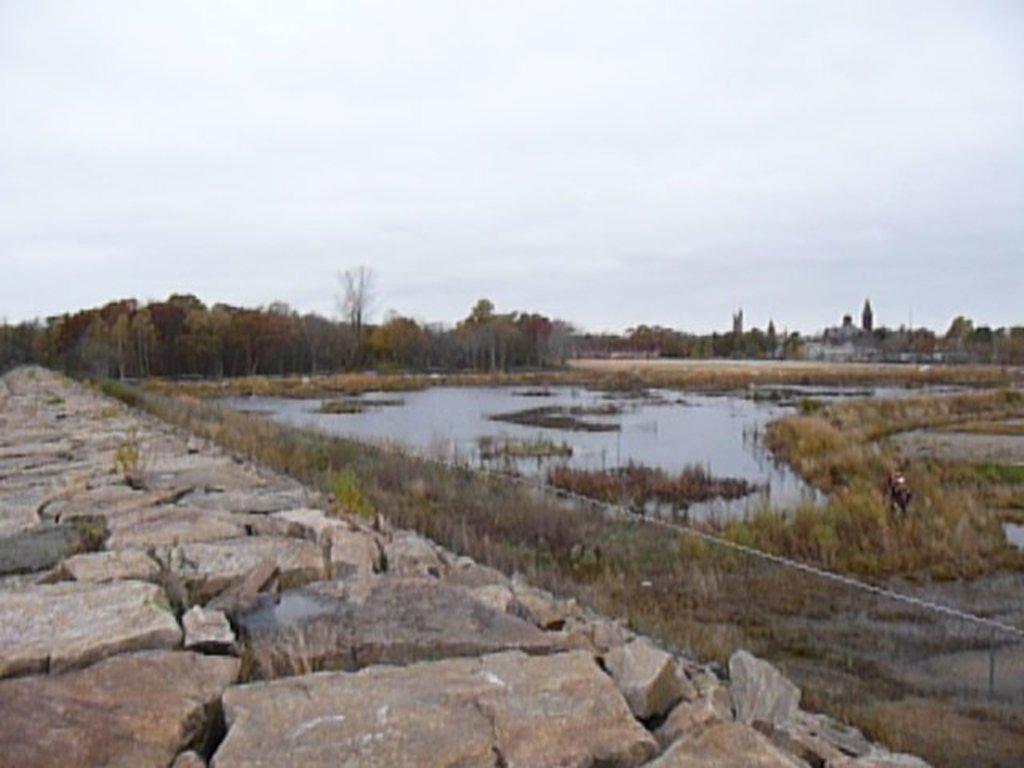Describe this image in one or two sentences. In this image I can see water, dried grass. Background I can see few trees in green color and few dried trees, and sky is in white color. 